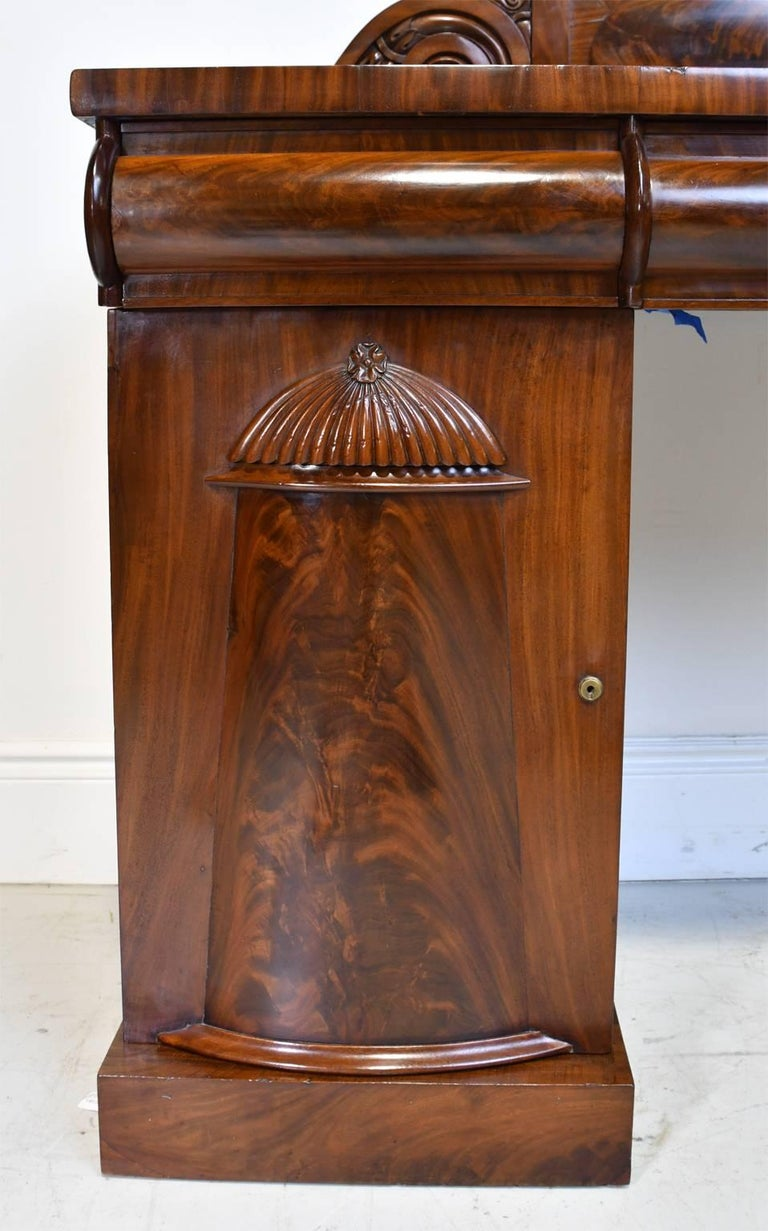Can you explain the significance of the shell motif on this furniture piece? The shell motif carved on the furniture section is significant and emblematic of the Rococo style, which was popular in Europe during the 18th century. This style is known for its ornate detailing and flowing lines, and the shell symbolizes a connection to nature, often associated with Venus, the goddess of love. In furniture design, such details were not only decorative but also intended to convey wealth and sophisticated taste. 